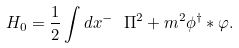Convert formula to latex. <formula><loc_0><loc_0><loc_500><loc_500>H _ { 0 } = \frac { 1 } { 2 } \int d x ^ { - } \ \Pi ^ { 2 } + m ^ { 2 } \phi ^ { \dag } \ast \varphi .</formula> 